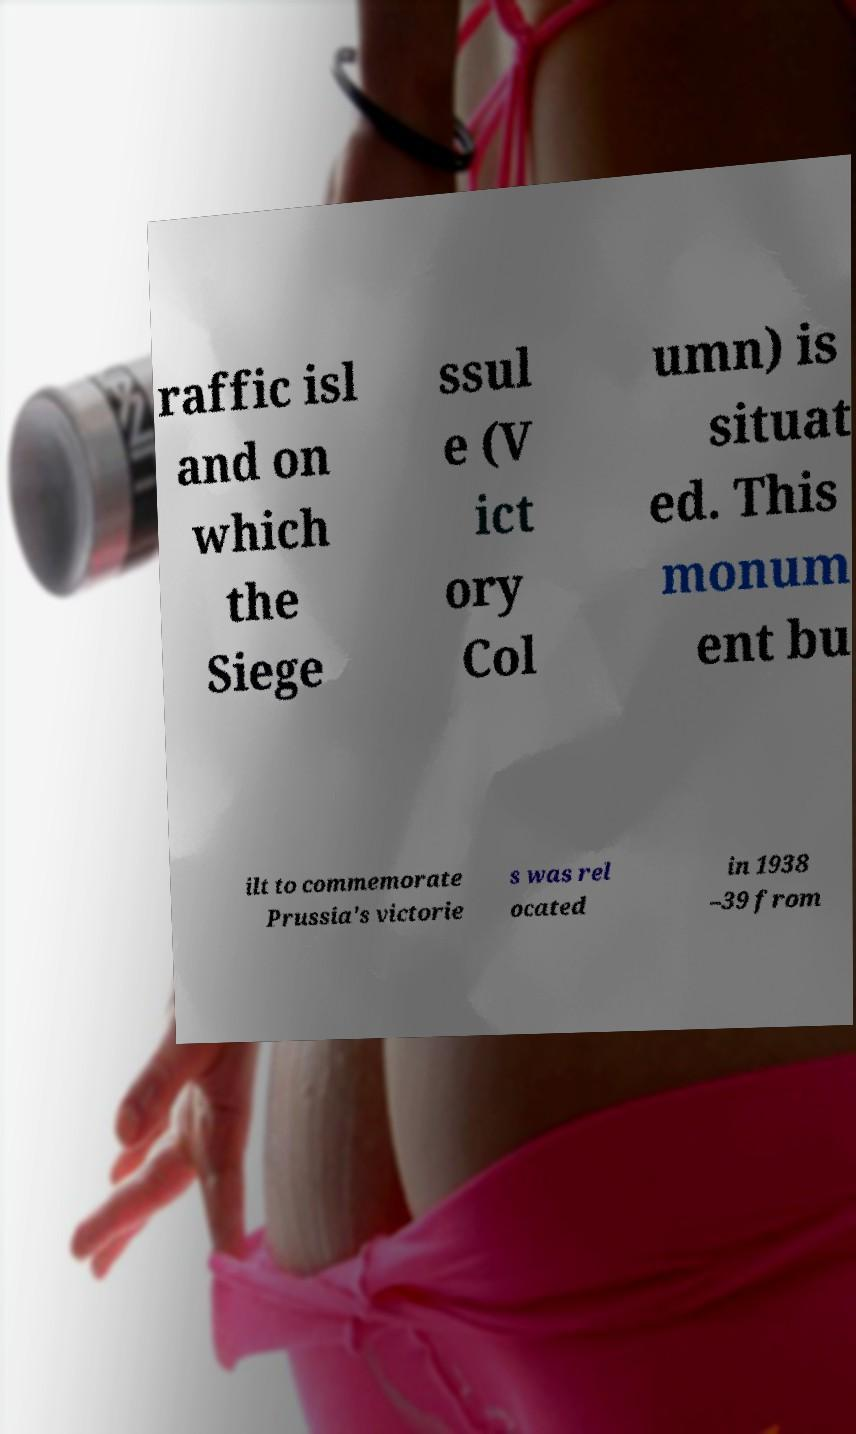Could you assist in decoding the text presented in this image and type it out clearly? raffic isl and on which the Siege ssul e (V ict ory Col umn) is situat ed. This monum ent bu ilt to commemorate Prussia's victorie s was rel ocated in 1938 –39 from 